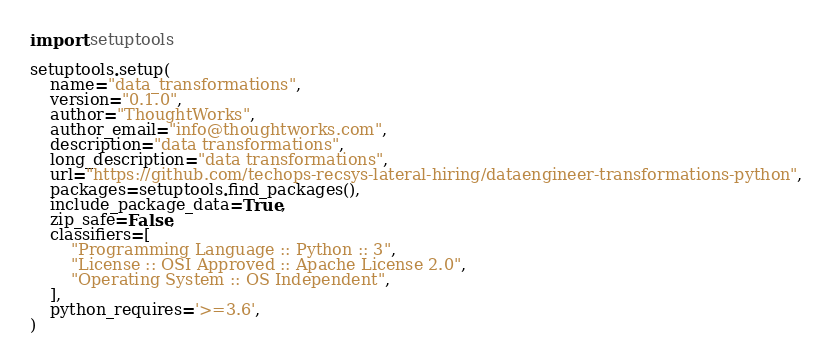<code> <loc_0><loc_0><loc_500><loc_500><_Python_>import setuptools

setuptools.setup(
    name="data_transformations",
    version="0.1.0",
    author="ThoughtWorks",
    author_email="info@thoughtworks.com",
    description="data transformations",
    long_description="data transformations",
    url="https://github.com/techops-recsys-lateral-hiring/dataengineer-transformations-python",
    packages=setuptools.find_packages(),
    include_package_data=True,
    zip_safe=False,
    classifiers=[
        "Programming Language :: Python :: 3",
        "License :: OSI Approved :: Apache License 2.0",
        "Operating System :: OS Independent",
    ],
    python_requires='>=3.6',
)
</code> 